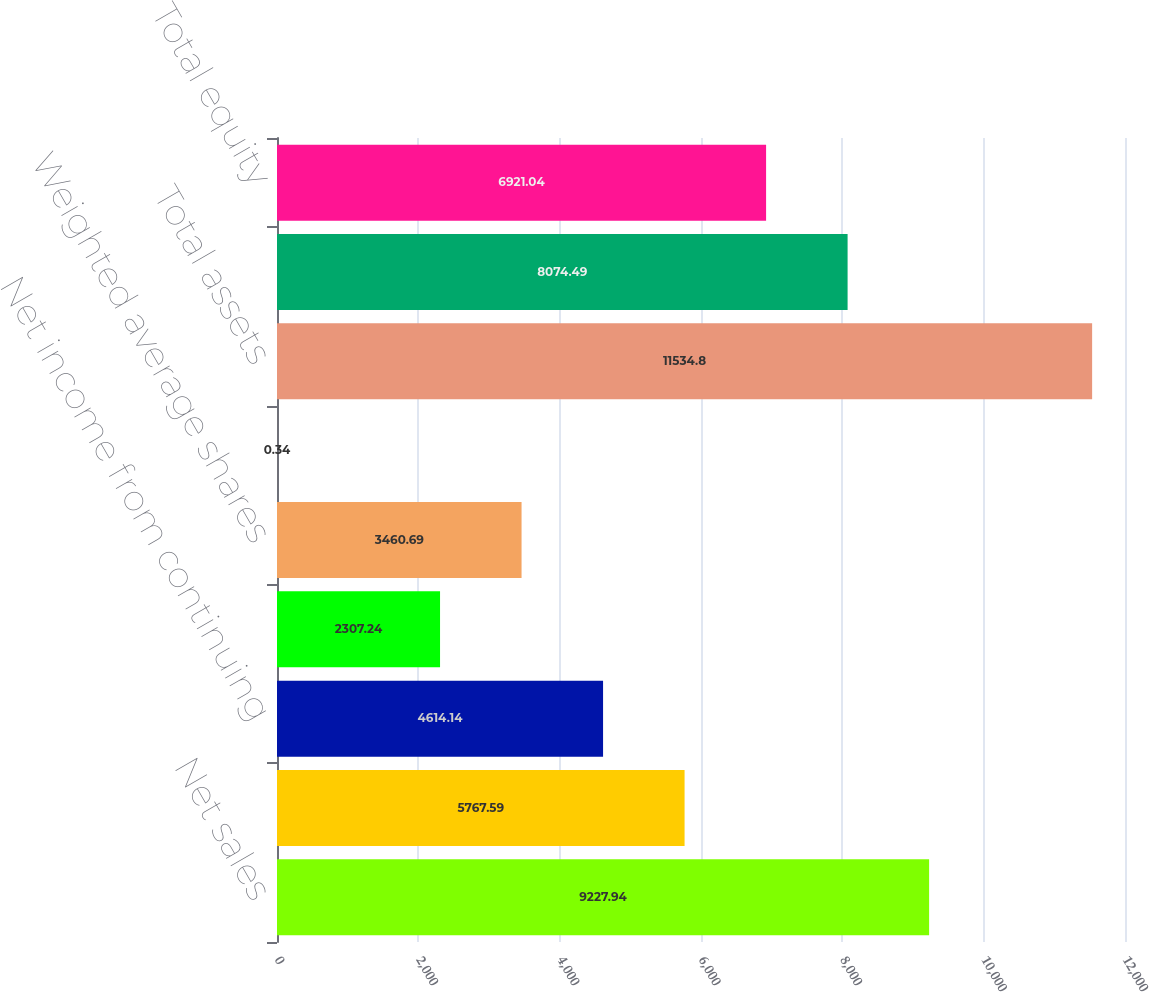Convert chart to OTSL. <chart><loc_0><loc_0><loc_500><loc_500><bar_chart><fcel>Net sales<fcel>Operating income<fcel>Net income from continuing<fcel>Earnings per ordinary share<fcel>Weighted average shares<fcel>Cash dividends declared and<fcel>Total assets<fcel>Total debt<fcel>Total equity<nl><fcel>9227.94<fcel>5767.59<fcel>4614.14<fcel>2307.24<fcel>3460.69<fcel>0.34<fcel>11534.8<fcel>8074.49<fcel>6921.04<nl></chart> 